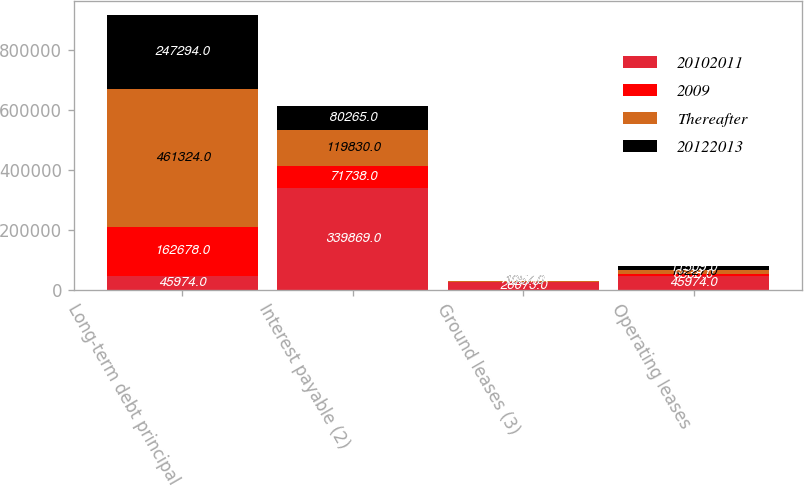Convert chart. <chart><loc_0><loc_0><loc_500><loc_500><stacked_bar_chart><ecel><fcel>Long-term debt principal<fcel>Interest payable (2)<fcel>Ground leases (3)<fcel>Operating leases<nl><fcel>20102011<fcel>45974<fcel>339869<fcel>26073<fcel>45974<nl><fcel>2009<fcel>162678<fcel>71738<fcel>529<fcel>6538<nl><fcel>Thereafter<fcel>461324<fcel>119830<fcel>1057<fcel>13227<nl><fcel>20122013<fcel>247294<fcel>80265<fcel>1057<fcel>11509<nl></chart> 